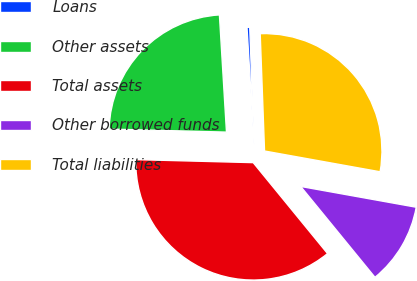Convert chart to OTSL. <chart><loc_0><loc_0><loc_500><loc_500><pie_chart><fcel>Loans<fcel>Other assets<fcel>Total assets<fcel>Other borrowed funds<fcel>Total liabilities<nl><fcel>0.37%<fcel>23.63%<fcel>36.32%<fcel>11.26%<fcel>28.42%<nl></chart> 